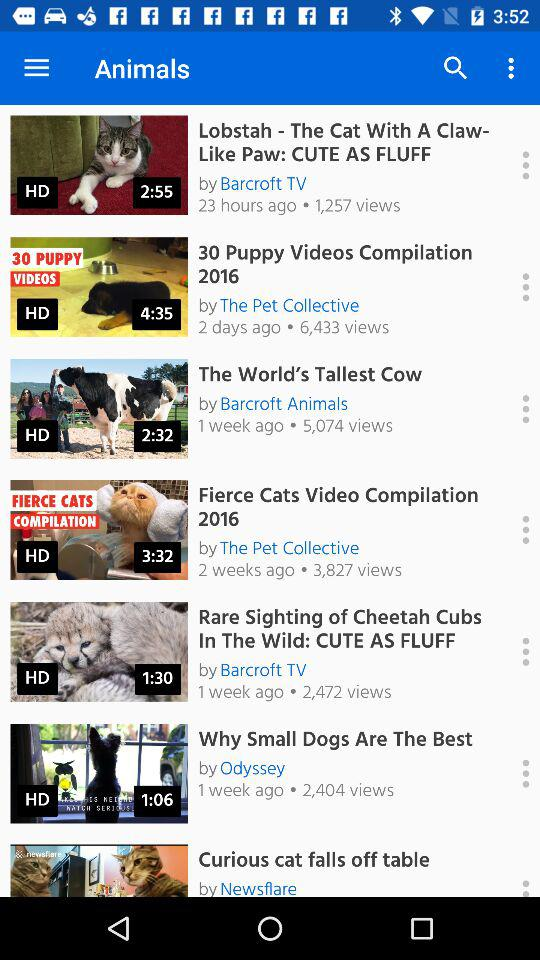How many weeks ago was the video "Fierce Cats Video Compilation 2016" uploaded? The video was uploaded 2 weeks ago. 